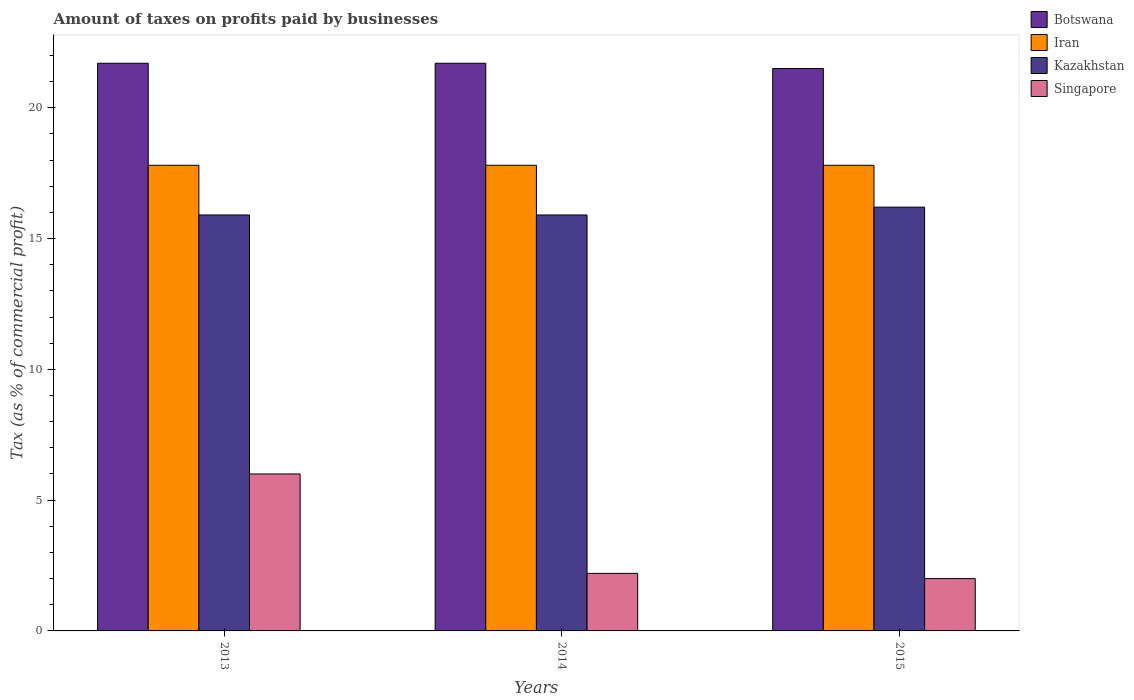How many different coloured bars are there?
Ensure brevity in your answer.  4. How many groups of bars are there?
Make the answer very short. 3. How many bars are there on the 2nd tick from the right?
Ensure brevity in your answer.  4. What is the label of the 3rd group of bars from the left?
Your response must be concise. 2015. What is the percentage of taxes paid by businesses in Iran in 2013?
Offer a very short reply. 17.8. Across all years, what is the maximum percentage of taxes paid by businesses in Botswana?
Offer a very short reply. 21.7. Across all years, what is the minimum percentage of taxes paid by businesses in Singapore?
Your answer should be compact. 2. In which year was the percentage of taxes paid by businesses in Kazakhstan minimum?
Offer a terse response. 2013. What is the total percentage of taxes paid by businesses in Iran in the graph?
Your answer should be very brief. 53.4. What is the difference between the percentage of taxes paid by businesses in Botswana in 2013 and that in 2015?
Your answer should be very brief. 0.2. What is the average percentage of taxes paid by businesses in Iran per year?
Your response must be concise. 17.8. In the year 2015, what is the difference between the percentage of taxes paid by businesses in Iran and percentage of taxes paid by businesses in Botswana?
Your response must be concise. -3.7. What is the ratio of the percentage of taxes paid by businesses in Iran in 2014 to that in 2015?
Provide a succinct answer. 1. Is the percentage of taxes paid by businesses in Singapore in 2013 less than that in 2015?
Make the answer very short. No. Is the difference between the percentage of taxes paid by businesses in Iran in 2013 and 2015 greater than the difference between the percentage of taxes paid by businesses in Botswana in 2013 and 2015?
Offer a very short reply. No. What is the difference between the highest and the second highest percentage of taxes paid by businesses in Botswana?
Provide a succinct answer. 0. What is the difference between the highest and the lowest percentage of taxes paid by businesses in Iran?
Provide a succinct answer. 0. Is the sum of the percentage of taxes paid by businesses in Iran in 2014 and 2015 greater than the maximum percentage of taxes paid by businesses in Singapore across all years?
Your answer should be compact. Yes. Is it the case that in every year, the sum of the percentage of taxes paid by businesses in Singapore and percentage of taxes paid by businesses in Kazakhstan is greater than the sum of percentage of taxes paid by businesses in Botswana and percentage of taxes paid by businesses in Iran?
Offer a very short reply. No. What does the 4th bar from the left in 2015 represents?
Ensure brevity in your answer.  Singapore. What does the 1st bar from the right in 2014 represents?
Offer a terse response. Singapore. How many years are there in the graph?
Keep it short and to the point. 3. Does the graph contain any zero values?
Provide a short and direct response. No. Where does the legend appear in the graph?
Make the answer very short. Top right. How many legend labels are there?
Ensure brevity in your answer.  4. How are the legend labels stacked?
Make the answer very short. Vertical. What is the title of the graph?
Ensure brevity in your answer.  Amount of taxes on profits paid by businesses. What is the label or title of the Y-axis?
Your answer should be very brief. Tax (as % of commercial profit). What is the Tax (as % of commercial profit) in Botswana in 2013?
Offer a very short reply. 21.7. What is the Tax (as % of commercial profit) of Singapore in 2013?
Provide a succinct answer. 6. What is the Tax (as % of commercial profit) in Botswana in 2014?
Your answer should be compact. 21.7. What is the Tax (as % of commercial profit) of Iran in 2014?
Your answer should be compact. 17.8. What is the Tax (as % of commercial profit) of Singapore in 2015?
Provide a short and direct response. 2. Across all years, what is the maximum Tax (as % of commercial profit) of Botswana?
Your response must be concise. 21.7. Across all years, what is the maximum Tax (as % of commercial profit) of Iran?
Offer a very short reply. 17.8. Across all years, what is the minimum Tax (as % of commercial profit) of Iran?
Your answer should be compact. 17.8. Across all years, what is the minimum Tax (as % of commercial profit) in Singapore?
Your answer should be compact. 2. What is the total Tax (as % of commercial profit) in Botswana in the graph?
Keep it short and to the point. 64.9. What is the total Tax (as % of commercial profit) of Iran in the graph?
Ensure brevity in your answer.  53.4. What is the total Tax (as % of commercial profit) of Singapore in the graph?
Give a very brief answer. 10.2. What is the difference between the Tax (as % of commercial profit) in Botswana in 2013 and that in 2014?
Your response must be concise. 0. What is the difference between the Tax (as % of commercial profit) in Iran in 2013 and that in 2014?
Offer a terse response. 0. What is the difference between the Tax (as % of commercial profit) in Kazakhstan in 2013 and that in 2014?
Give a very brief answer. 0. What is the difference between the Tax (as % of commercial profit) of Singapore in 2013 and that in 2014?
Provide a short and direct response. 3.8. What is the difference between the Tax (as % of commercial profit) in Iran in 2013 and that in 2015?
Your response must be concise. 0. What is the difference between the Tax (as % of commercial profit) of Singapore in 2013 and that in 2015?
Your response must be concise. 4. What is the difference between the Tax (as % of commercial profit) in Botswana in 2013 and the Tax (as % of commercial profit) in Kazakhstan in 2014?
Provide a succinct answer. 5.8. What is the difference between the Tax (as % of commercial profit) in Botswana in 2013 and the Tax (as % of commercial profit) in Singapore in 2014?
Offer a terse response. 19.5. What is the difference between the Tax (as % of commercial profit) of Botswana in 2013 and the Tax (as % of commercial profit) of Iran in 2015?
Give a very brief answer. 3.9. What is the difference between the Tax (as % of commercial profit) in Iran in 2013 and the Tax (as % of commercial profit) in Kazakhstan in 2015?
Make the answer very short. 1.6. What is the difference between the Tax (as % of commercial profit) of Iran in 2013 and the Tax (as % of commercial profit) of Singapore in 2015?
Your answer should be very brief. 15.8. What is the difference between the Tax (as % of commercial profit) in Kazakhstan in 2013 and the Tax (as % of commercial profit) in Singapore in 2015?
Your answer should be compact. 13.9. What is the difference between the Tax (as % of commercial profit) of Botswana in 2014 and the Tax (as % of commercial profit) of Singapore in 2015?
Offer a terse response. 19.7. What is the difference between the Tax (as % of commercial profit) in Iran in 2014 and the Tax (as % of commercial profit) in Kazakhstan in 2015?
Provide a short and direct response. 1.6. What is the difference between the Tax (as % of commercial profit) of Iran in 2014 and the Tax (as % of commercial profit) of Singapore in 2015?
Your answer should be very brief. 15.8. What is the difference between the Tax (as % of commercial profit) in Kazakhstan in 2014 and the Tax (as % of commercial profit) in Singapore in 2015?
Offer a terse response. 13.9. What is the average Tax (as % of commercial profit) of Botswana per year?
Offer a very short reply. 21.63. What is the average Tax (as % of commercial profit) of Iran per year?
Your answer should be very brief. 17.8. What is the average Tax (as % of commercial profit) of Kazakhstan per year?
Make the answer very short. 16. What is the average Tax (as % of commercial profit) in Singapore per year?
Provide a short and direct response. 3.4. In the year 2013, what is the difference between the Tax (as % of commercial profit) of Botswana and Tax (as % of commercial profit) of Iran?
Provide a short and direct response. 3.9. In the year 2013, what is the difference between the Tax (as % of commercial profit) of Botswana and Tax (as % of commercial profit) of Singapore?
Provide a succinct answer. 15.7. In the year 2013, what is the difference between the Tax (as % of commercial profit) in Iran and Tax (as % of commercial profit) in Kazakhstan?
Give a very brief answer. 1.9. In the year 2013, what is the difference between the Tax (as % of commercial profit) of Kazakhstan and Tax (as % of commercial profit) of Singapore?
Your answer should be compact. 9.9. In the year 2014, what is the difference between the Tax (as % of commercial profit) in Botswana and Tax (as % of commercial profit) in Kazakhstan?
Your answer should be compact. 5.8. In the year 2014, what is the difference between the Tax (as % of commercial profit) in Botswana and Tax (as % of commercial profit) in Singapore?
Make the answer very short. 19.5. In the year 2014, what is the difference between the Tax (as % of commercial profit) of Iran and Tax (as % of commercial profit) of Kazakhstan?
Offer a very short reply. 1.9. In the year 2014, what is the difference between the Tax (as % of commercial profit) of Iran and Tax (as % of commercial profit) of Singapore?
Your answer should be very brief. 15.6. In the year 2015, what is the difference between the Tax (as % of commercial profit) in Botswana and Tax (as % of commercial profit) in Singapore?
Your answer should be very brief. 19.5. In the year 2015, what is the difference between the Tax (as % of commercial profit) in Kazakhstan and Tax (as % of commercial profit) in Singapore?
Give a very brief answer. 14.2. What is the ratio of the Tax (as % of commercial profit) of Iran in 2013 to that in 2014?
Provide a short and direct response. 1. What is the ratio of the Tax (as % of commercial profit) in Kazakhstan in 2013 to that in 2014?
Give a very brief answer. 1. What is the ratio of the Tax (as % of commercial profit) in Singapore in 2013 to that in 2014?
Offer a terse response. 2.73. What is the ratio of the Tax (as % of commercial profit) in Botswana in 2013 to that in 2015?
Provide a short and direct response. 1.01. What is the ratio of the Tax (as % of commercial profit) in Kazakhstan in 2013 to that in 2015?
Offer a very short reply. 0.98. What is the ratio of the Tax (as % of commercial profit) of Botswana in 2014 to that in 2015?
Your response must be concise. 1.01. What is the ratio of the Tax (as % of commercial profit) in Iran in 2014 to that in 2015?
Offer a terse response. 1. What is the ratio of the Tax (as % of commercial profit) of Kazakhstan in 2014 to that in 2015?
Ensure brevity in your answer.  0.98. What is the ratio of the Tax (as % of commercial profit) of Singapore in 2014 to that in 2015?
Your answer should be very brief. 1.1. What is the difference between the highest and the second highest Tax (as % of commercial profit) of Botswana?
Your answer should be compact. 0. What is the difference between the highest and the second highest Tax (as % of commercial profit) of Kazakhstan?
Your answer should be very brief. 0.3. What is the difference between the highest and the lowest Tax (as % of commercial profit) of Singapore?
Provide a succinct answer. 4. 